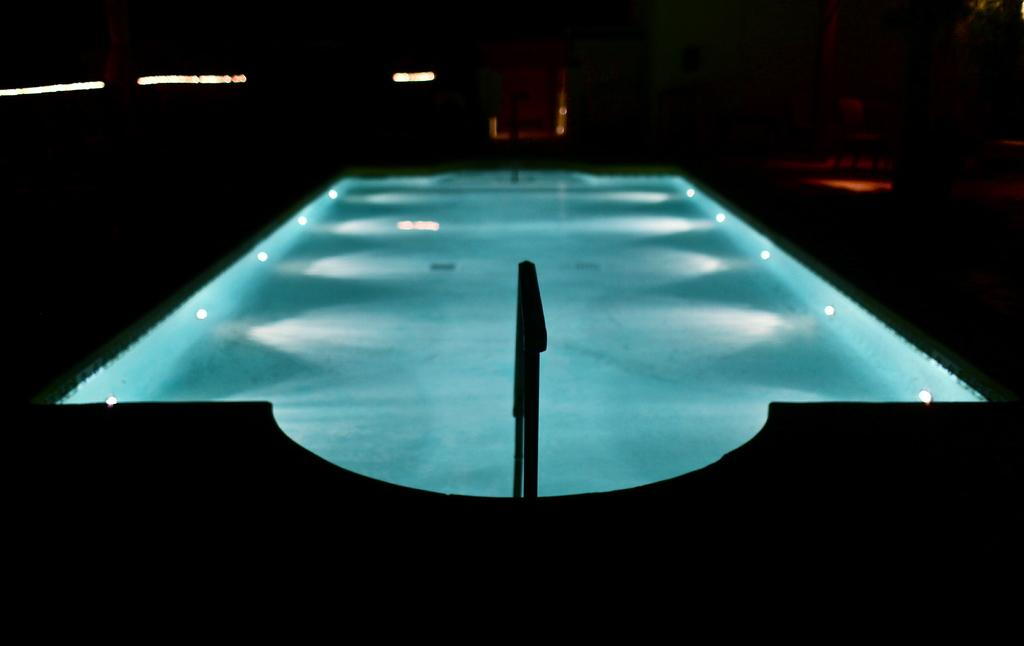Where was the image taken? The image was taken indoors. What can be observed about the lighting in the image? The background of the image is dark. What is the main subject in the middle of the image? There is a swimming pool with water in the middle of the image. Are there any additional features in the swimming pool? Yes, there are a few lights visible in the swimming pool. What type of cart is being used to transport the beads in the image? There is no cart or beads present in the image. 